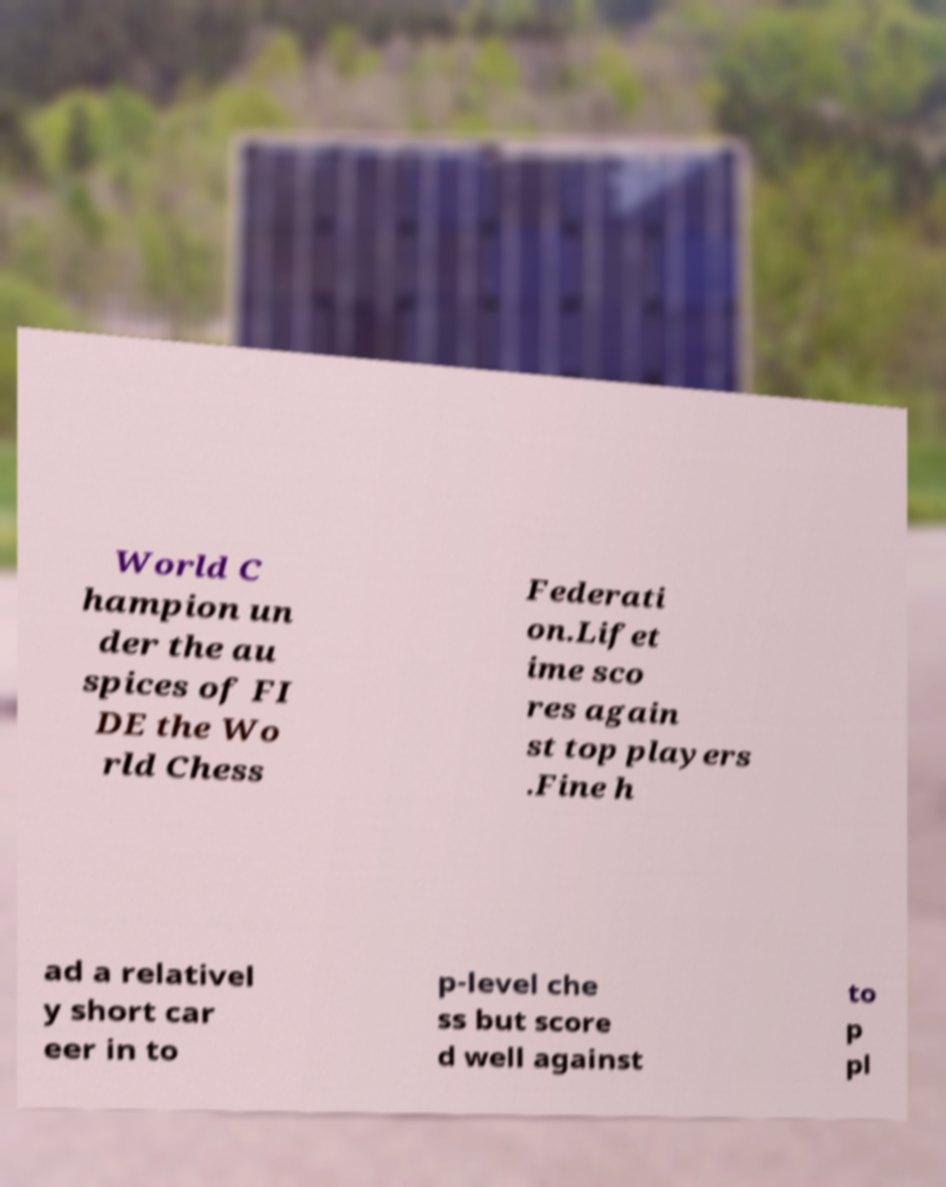Could you assist in decoding the text presented in this image and type it out clearly? World C hampion un der the au spices of FI DE the Wo rld Chess Federati on.Lifet ime sco res again st top players .Fine h ad a relativel y short car eer in to p-level che ss but score d well against to p pl 